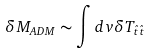<formula> <loc_0><loc_0><loc_500><loc_500>\delta M _ { A D M } \sim \int d v \delta T _ { \hat { t } \hat { t } }</formula> 